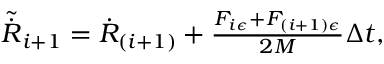<formula> <loc_0><loc_0><loc_500><loc_500>\begin{array} { r } { \tilde { \dot { R } } _ { i + 1 } = \dot { R } _ { ( i + 1 ) } + \frac { F _ { i \epsilon } + F _ { ( i + 1 ) \epsilon } } { 2 M } \Delta t , } \end{array}</formula> 